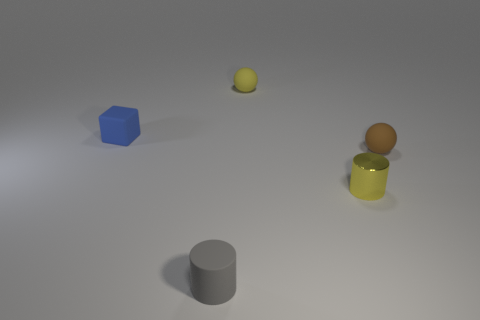Is there any other thing that has the same material as the small yellow cylinder?
Ensure brevity in your answer.  No. Is there anything else that has the same color as the small matte cube?
Provide a succinct answer. No. The other tiny thing that is the same color as the small metallic object is what shape?
Give a very brief answer. Sphere. Are there any gray things that have the same shape as the small yellow metal thing?
Your response must be concise. Yes. There is a matte cylinder that is the same size as the blue object; what color is it?
Provide a short and direct response. Gray. There is a tiny ball that is on the left side of the small cylinder that is to the right of the gray matte cylinder; what color is it?
Give a very brief answer. Yellow. Is the color of the sphere that is to the left of the yellow metal object the same as the tiny metallic cylinder?
Make the answer very short. Yes. There is a matte thing that is in front of the tiny brown sphere that is right of the yellow metallic cylinder to the right of the gray matte object; what shape is it?
Ensure brevity in your answer.  Cylinder. There is a tiny cylinder that is behind the matte cylinder; what number of small yellow matte objects are behind it?
Provide a short and direct response. 1. Are the blue block and the yellow cylinder made of the same material?
Offer a very short reply. No. 